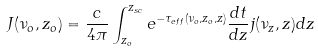Convert formula to latex. <formula><loc_0><loc_0><loc_500><loc_500>J ( \nu _ { o } , z _ { o } ) = \frac { c } { 4 \pi } \int ^ { z _ { s c } } _ { z _ { o } } e ^ { - \tau _ { e f f } ( \nu _ { o } , z _ { o } , z ) } \frac { d t } { d z } j ( \nu _ { z } , z ) d z</formula> 